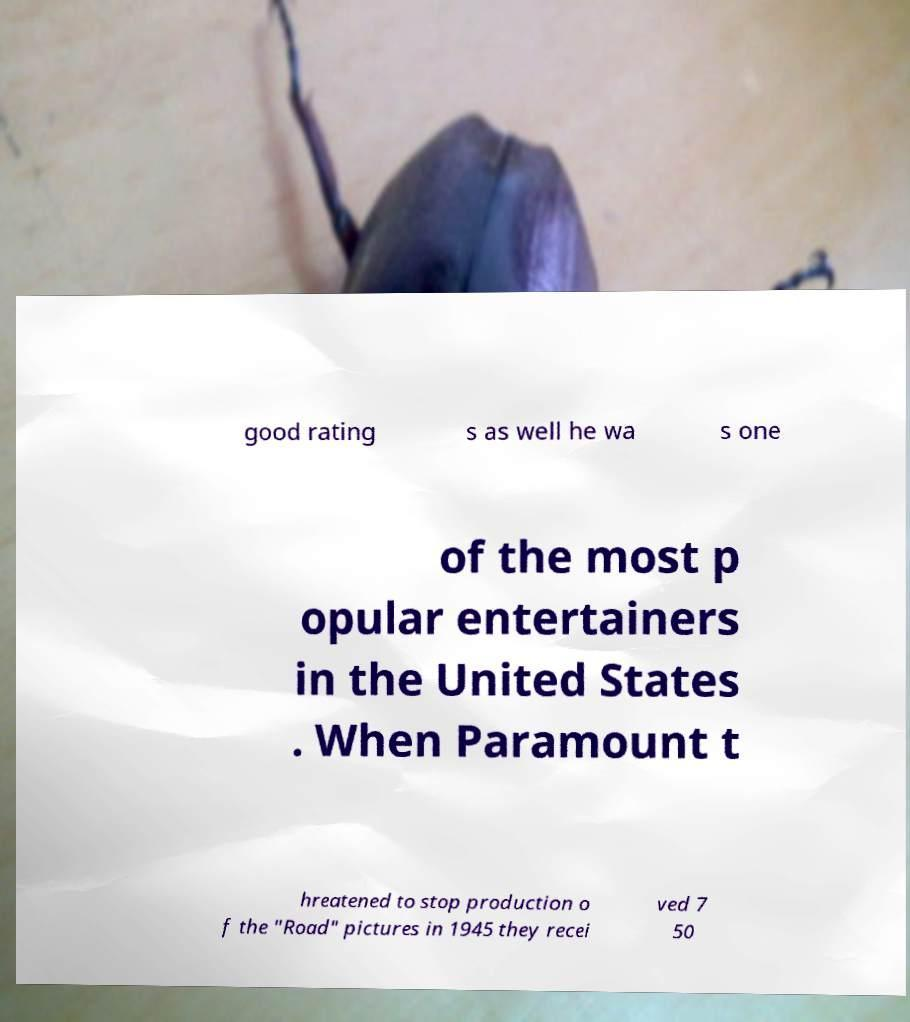What messages or text are displayed in this image? I need them in a readable, typed format. good rating s as well he wa s one of the most p opular entertainers in the United States . When Paramount t hreatened to stop production o f the "Road" pictures in 1945 they recei ved 7 50 